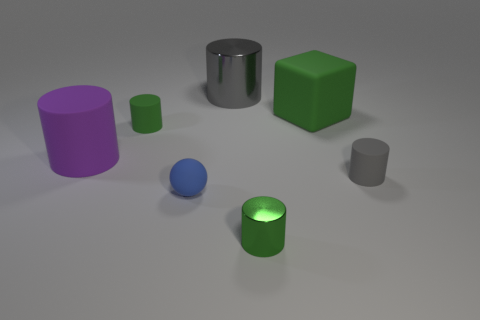Subtract all small green cylinders. How many cylinders are left? 3 Subtract all yellow blocks. How many gray cylinders are left? 2 Subtract 2 cylinders. How many cylinders are left? 3 Subtract all gray cylinders. How many cylinders are left? 3 Subtract all blue cylinders. Subtract all red balls. How many cylinders are left? 5 Add 1 purple rubber objects. How many objects exist? 8 Subtract all cylinders. How many objects are left? 2 Add 5 large red rubber cylinders. How many large red rubber cylinders exist? 5 Subtract 0 blue cylinders. How many objects are left? 7 Subtract all large purple rubber cylinders. Subtract all small blue balls. How many objects are left? 5 